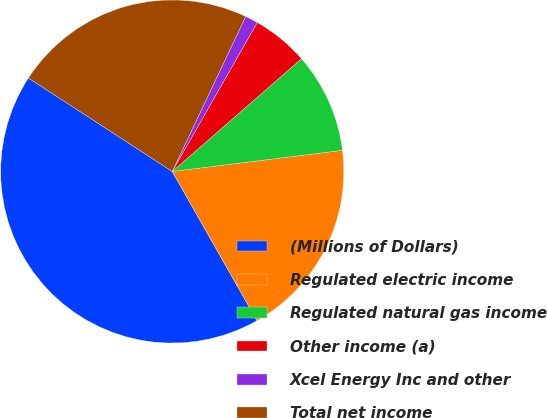<chart> <loc_0><loc_0><loc_500><loc_500><pie_chart><fcel>(Millions of Dollars)<fcel>Regulated electric income<fcel>Regulated natural gas income<fcel>Other income (a)<fcel>Xcel Energy Inc and other<fcel>Total net income<nl><fcel>42.4%<fcel>18.75%<fcel>9.45%<fcel>5.33%<fcel>1.21%<fcel>22.87%<nl></chart> 